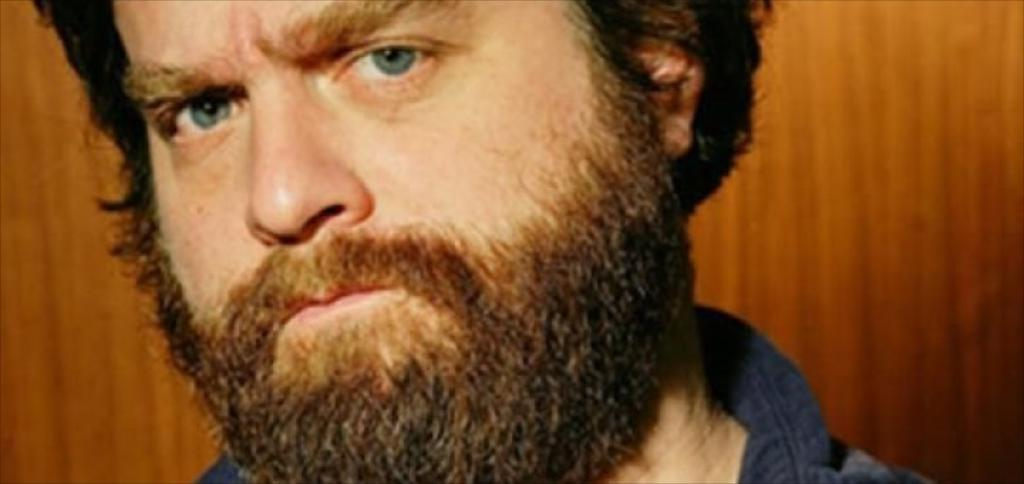What is the main subject of the image? There is a person in the image. What type of class is the person attending in the image? There is no indication of a class or any educational setting in the image; it only features a person. 